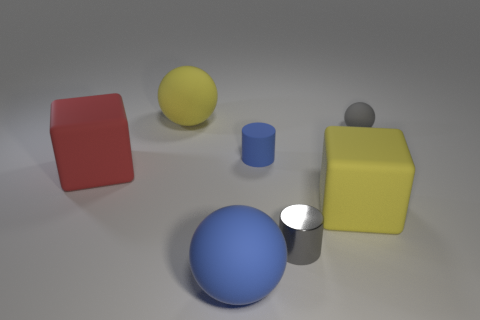Is there anything else that is the same material as the small gray cylinder?
Provide a succinct answer. No. Does the yellow thing on the right side of the blue matte cylinder have the same shape as the red object?
Your response must be concise. Yes. The gray metallic thing has what shape?
Give a very brief answer. Cylinder. How many large yellow blocks have the same material as the gray cylinder?
Offer a terse response. 0. There is a tiny metallic object; is it the same color as the cube that is behind the big yellow matte cube?
Keep it short and to the point. No. How many small blue shiny cylinders are there?
Provide a succinct answer. 0. Is there a tiny thing that has the same color as the tiny metal cylinder?
Your answer should be compact. Yes. There is a matte cube that is right of the large thing to the left of the rubber thing that is behind the gray matte sphere; what is its color?
Ensure brevity in your answer.  Yellow. Is the material of the blue sphere the same as the big yellow thing right of the large blue thing?
Your answer should be compact. Yes. What material is the tiny gray ball?
Offer a terse response. Rubber. 